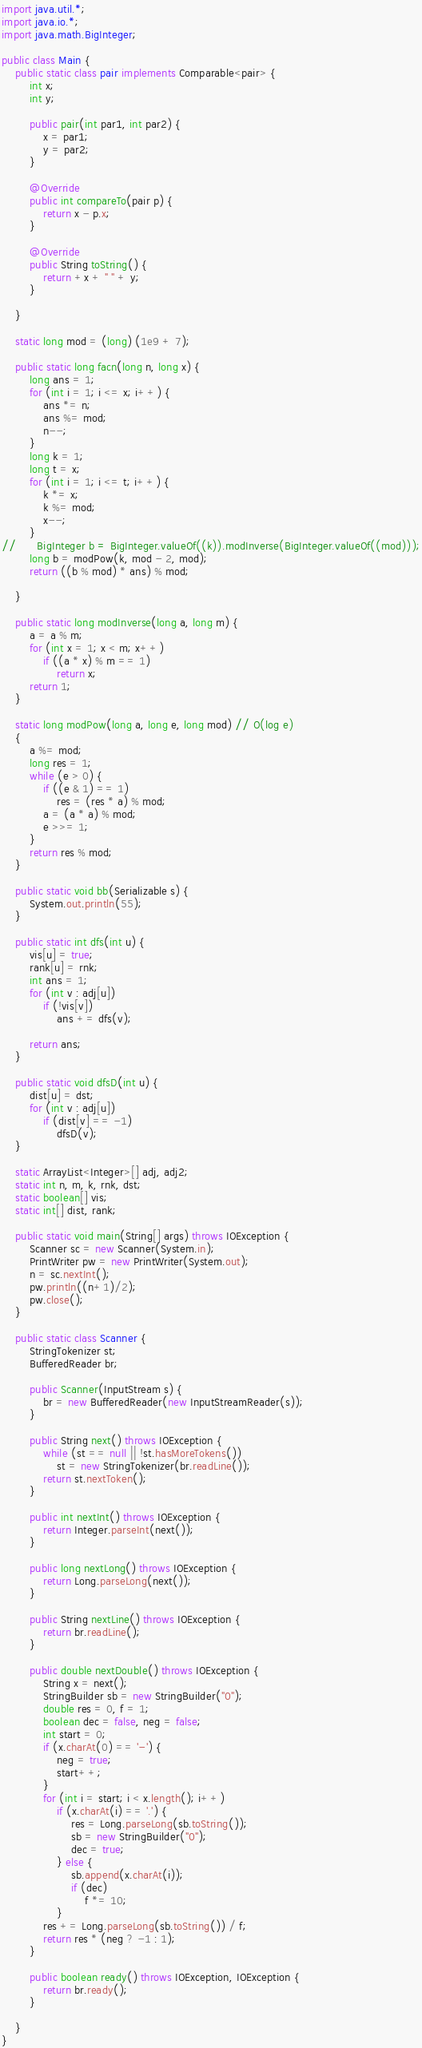<code> <loc_0><loc_0><loc_500><loc_500><_Java_>import java.util.*;
import java.io.*;
import java.math.BigInteger;

public class Main {
	public static class pair implements Comparable<pair> {
		int x;
		int y;

		public pair(int par1, int par2) {
			x = par1;
			y = par2;
		}

		@Override
		public int compareTo(pair p) {
			return x - p.x;
		}

		@Override
		public String toString() {
			return +x + " " + y;
		}

	}

	static long mod = (long) (1e9 + 7);

	public static long facn(long n, long x) {
		long ans = 1;
		for (int i = 1; i <= x; i++) {
			ans *= n;
			ans %= mod;
			n--;
		}
		long k = 1;
		long t = x;
		for (int i = 1; i <= t; i++) {
			k *= x;
			k %= mod;
			x--;
		}
//		BigInteger b = BigInteger.valueOf((k)).modInverse(BigInteger.valueOf((mod)));
		long b = modPow(k, mod - 2, mod);
		return ((b % mod) * ans) % mod;

	}

	public static long modInverse(long a, long m) {
		a = a % m;
		for (int x = 1; x < m; x++)
			if ((a * x) % m == 1)
				return x;
		return 1;
	}

	static long modPow(long a, long e, long mod) // O(log e)
	{
		a %= mod;
		long res = 1;
		while (e > 0) {
			if ((e & 1) == 1)
				res = (res * a) % mod;
			a = (a * a) % mod;
			e >>= 1;
		}
		return res % mod;
	}

	public static void bb(Serializable s) {
		System.out.println(55);
	}

	public static int dfs(int u) {
		vis[u] = true;
		rank[u] = rnk;
		int ans = 1;
		for (int v : adj[u])
			if (!vis[v])
				ans += dfs(v);

		return ans;
	}

	public static void dfsD(int u) {
		dist[u] = dst;
		for (int v : adj[u])
			if (dist[v] == -1)
				dfsD(v);
	}

	static ArrayList<Integer>[] adj, adj2;
	static int n, m, k, rnk, dst;
	static boolean[] vis;
	static int[] dist, rank;

	public static void main(String[] args) throws IOException {
		Scanner sc = new Scanner(System.in);
		PrintWriter pw = new PrintWriter(System.out);
		n = sc.nextInt();
		pw.println((n+1)/2);
		pw.close();
	}

	public static class Scanner {
		StringTokenizer st;
		BufferedReader br;

		public Scanner(InputStream s) {
			br = new BufferedReader(new InputStreamReader(s));
		}

		public String next() throws IOException {
			while (st == null || !st.hasMoreTokens())
				st = new StringTokenizer(br.readLine());
			return st.nextToken();
		}

		public int nextInt() throws IOException {
			return Integer.parseInt(next());
		}

		public long nextLong() throws IOException {
			return Long.parseLong(next());
		}

		public String nextLine() throws IOException {
			return br.readLine();
		}

		public double nextDouble() throws IOException {
			String x = next();
			StringBuilder sb = new StringBuilder("0");
			double res = 0, f = 1;
			boolean dec = false, neg = false;
			int start = 0;
			if (x.charAt(0) == '-') {
				neg = true;
				start++;
			}
			for (int i = start; i < x.length(); i++)
				if (x.charAt(i) == '.') {
					res = Long.parseLong(sb.toString());
					sb = new StringBuilder("0");
					dec = true;
				} else {
					sb.append(x.charAt(i));
					if (dec)
						f *= 10;
				}
			res += Long.parseLong(sb.toString()) / f;
			return res * (neg ? -1 : 1);
		}

		public boolean ready() throws IOException, IOException {
			return br.ready();
		}

	}
}</code> 